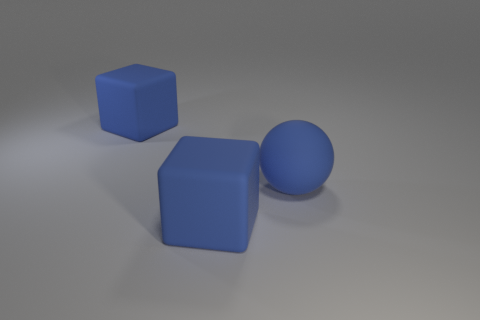How many green things are big balls or tiny spheres?
Your answer should be compact. 0. Is the number of rubber things that are behind the large blue sphere the same as the number of blue matte objects?
Your answer should be compact. No. Is there anything else that has the same color as the big ball?
Ensure brevity in your answer.  Yes. How many other objects are the same size as the rubber ball?
Your response must be concise. 2. Do the blue ball and the blue thing that is behind the large rubber ball have the same size?
Offer a terse response. Yes. Is the material of the big blue block that is in front of the large matte ball the same as the big sphere?
Make the answer very short. Yes. There is a blue rubber thing left of the rubber cube to the right of the matte cube behind the large ball; what shape is it?
Offer a very short reply. Cube. There is a matte object that is behind the large blue sphere; is it the same shape as the big object in front of the matte sphere?
Provide a short and direct response. Yes. Are there any other big blue balls made of the same material as the ball?
Make the answer very short. No. Do the blue object that is behind the big matte ball and the blue object in front of the sphere have the same material?
Your response must be concise. Yes. 